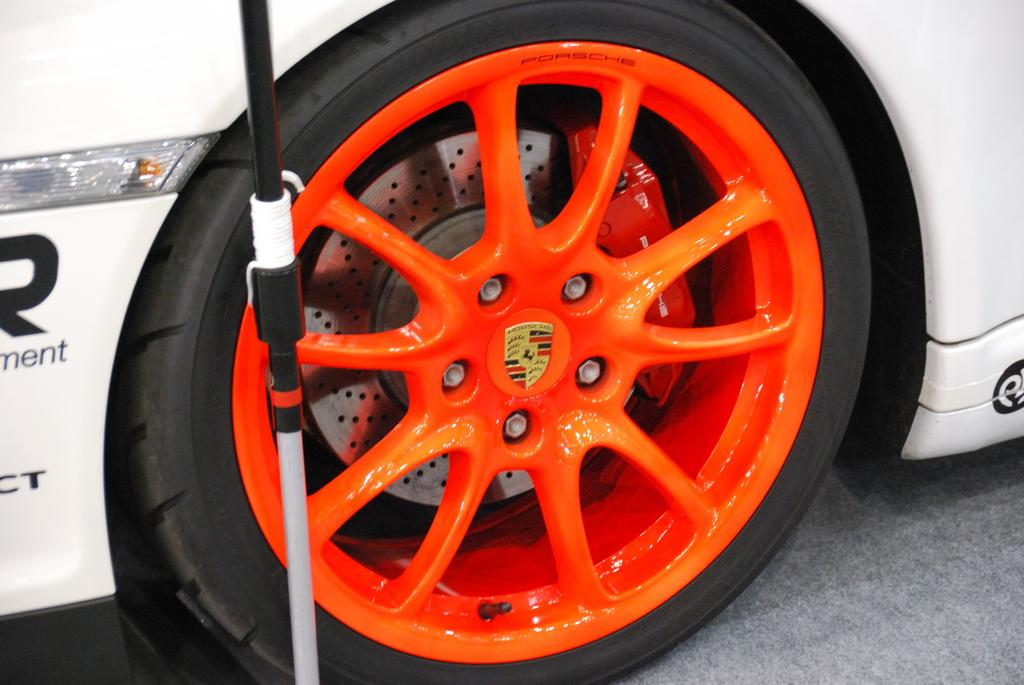What color is the car in the image? The car in the image is white. What is unique about the car's wheels? The car's wheels have orange color wheel alloys. Are the wheel alloys connected to the tires? Yes, the wheel alloys are attached to the tires. What additional object can be seen in the image? There is a stick visible in the image. What advice do the bears in the image give to the car owner? There are no bears present in the image, so no advice can be given by them. 